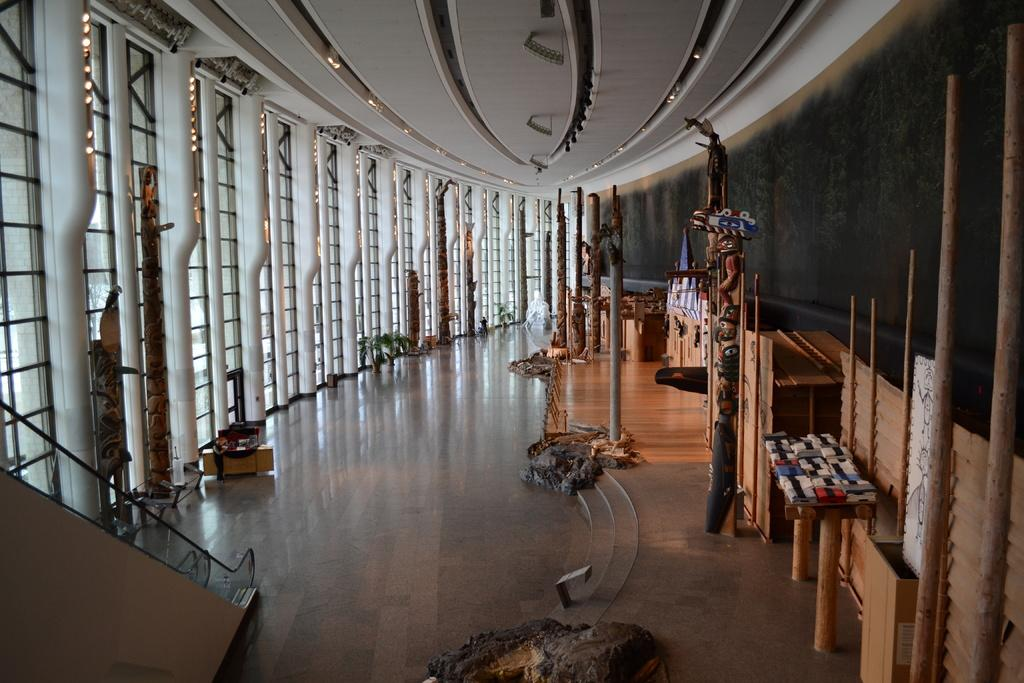What type of structure can be seen in the image? There is a railing in the image, which suggests a structure like a balcony or staircase. What is above the objects in the image? There is a ceiling in the image. What allows natural light to enter the space in the image? There are windows in the image. What type of vegetation is present in the image? There are plants in the image. What provides illumination in the image? There are lights in the image. What supports the structure in the image? There are poles in the image. What type of furniture is present in the image? There are tables in the image. What type of flooring is visible in the image? There is a wooden floor in the image. What else can be seen in the image besides the mentioned elements? There are objects in the image. How does love manifest itself in the image? Love is not a tangible element that can be seen or manifested in the image. --- Facts: 1. There is a car in the image. 12. The car is red. 13. The car has four wheels. 14. The car has a sunroof. 15. The car has a spoiler. 16. The car has a license plate. 17. The car has a front bumper. 18. The car has a rear bumper. 19. The car has a trunk. 120. The car has a hood. 121. The car has a windshield. 122. The car has a rearview mirror. 123. The car has a steering wheel. 124. The car has a dashboard. 125. The car has a driver's seat. 126. The car has a passenger's seat. 127. The car has a backseat. 128. The car has a set of doors. 129. The car has a set of windows. 130. The car has a set of tires. Absurd Topics: unicorn, rainbow, magic Conversation: What type of vehicle is in the image? There is a car in the image. What is the color of the car in the image? The car is red in the image. How many wheels does the car have in the image? The car has four wheels in the image. What type of feature does the car have in the image? The car has a sunroof in the image. What type of feature does the car have in the image? The car has a spoiler in the image. What type of feature does the car have in the image? The car has a license plate in the 